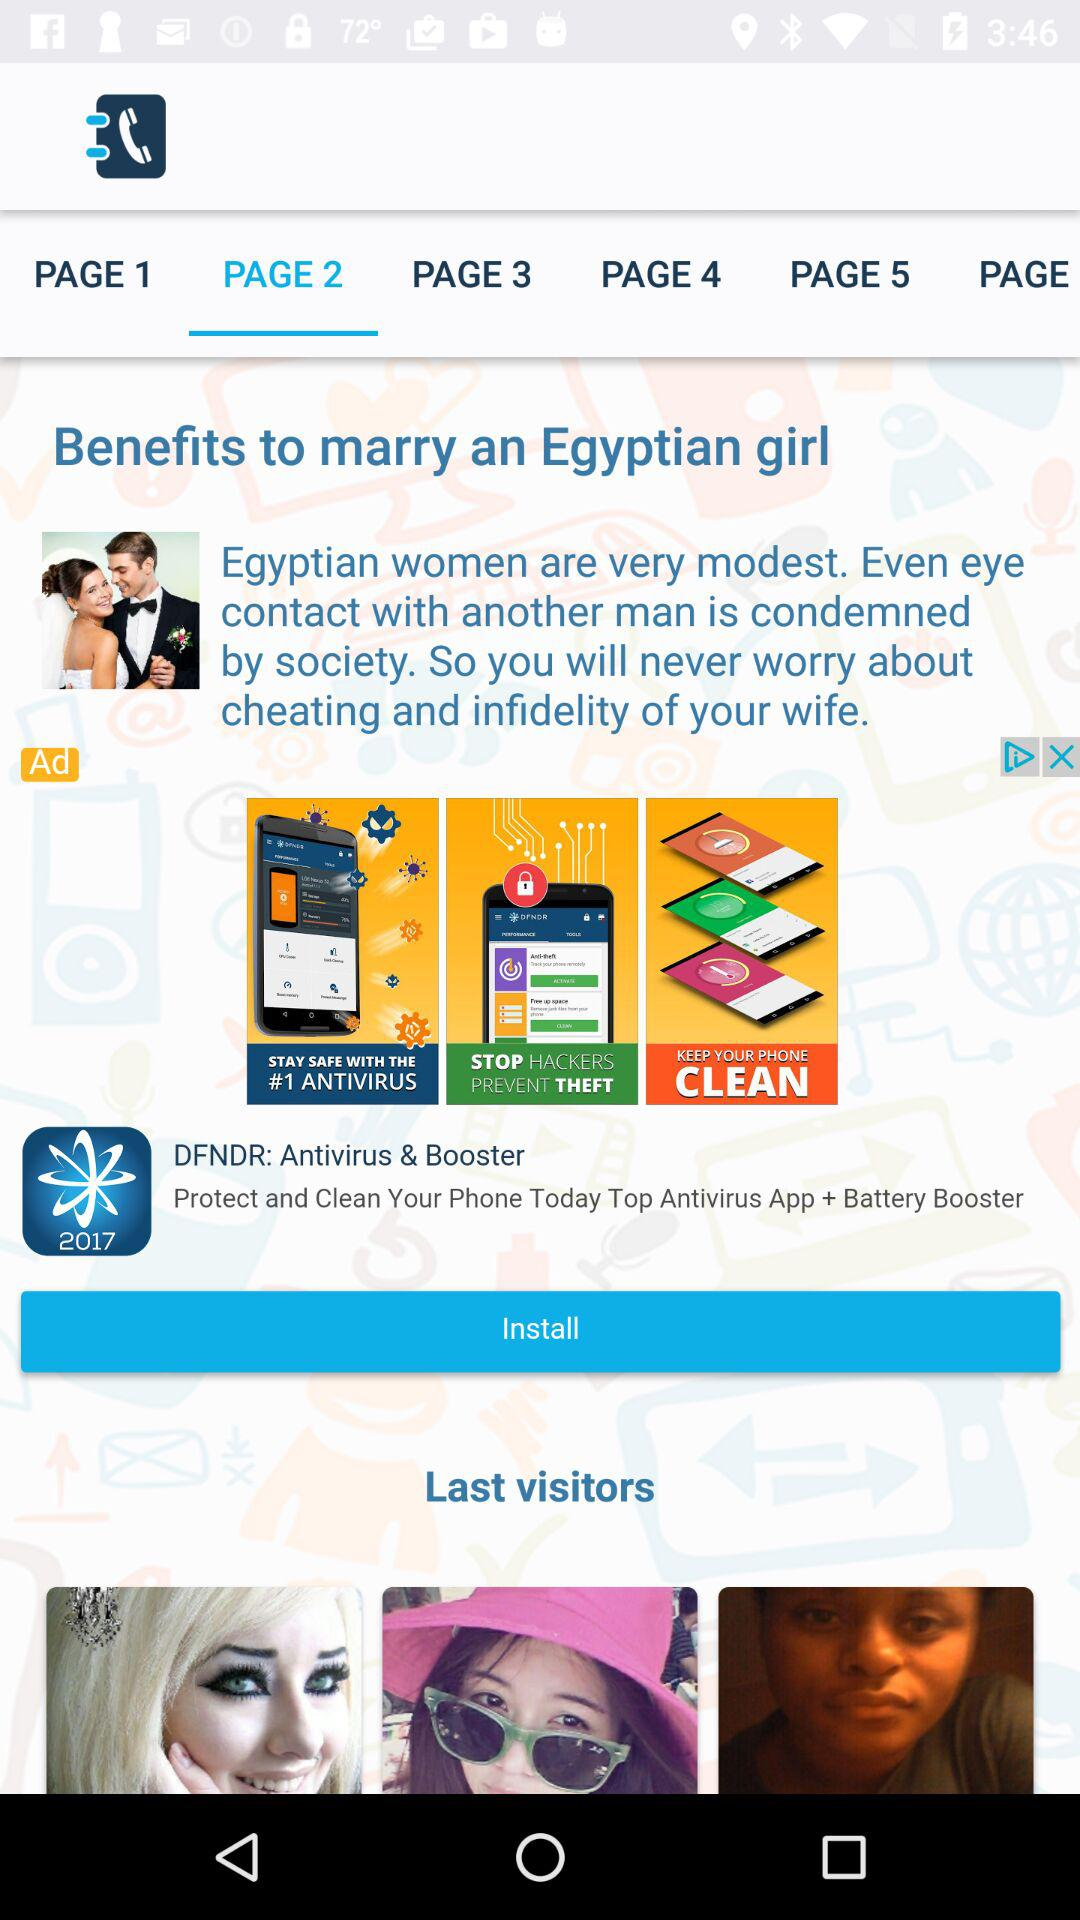Which items are on page 5?
When the provided information is insufficient, respond with <no answer>. <no answer> 